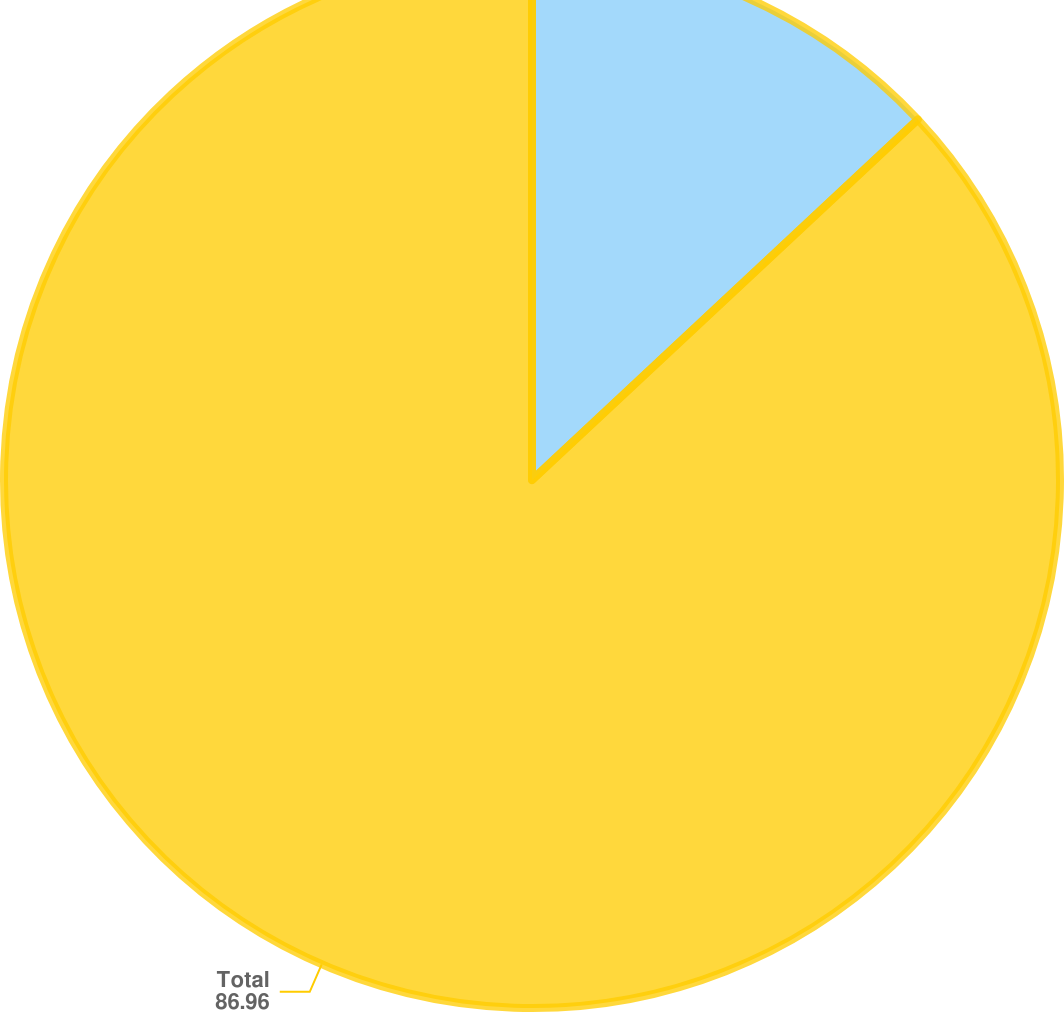Convert chart to OTSL. <chart><loc_0><loc_0><loc_500><loc_500><pie_chart><fcel>Three months or less<fcel>Total<nl><fcel>13.04%<fcel>86.96%<nl></chart> 